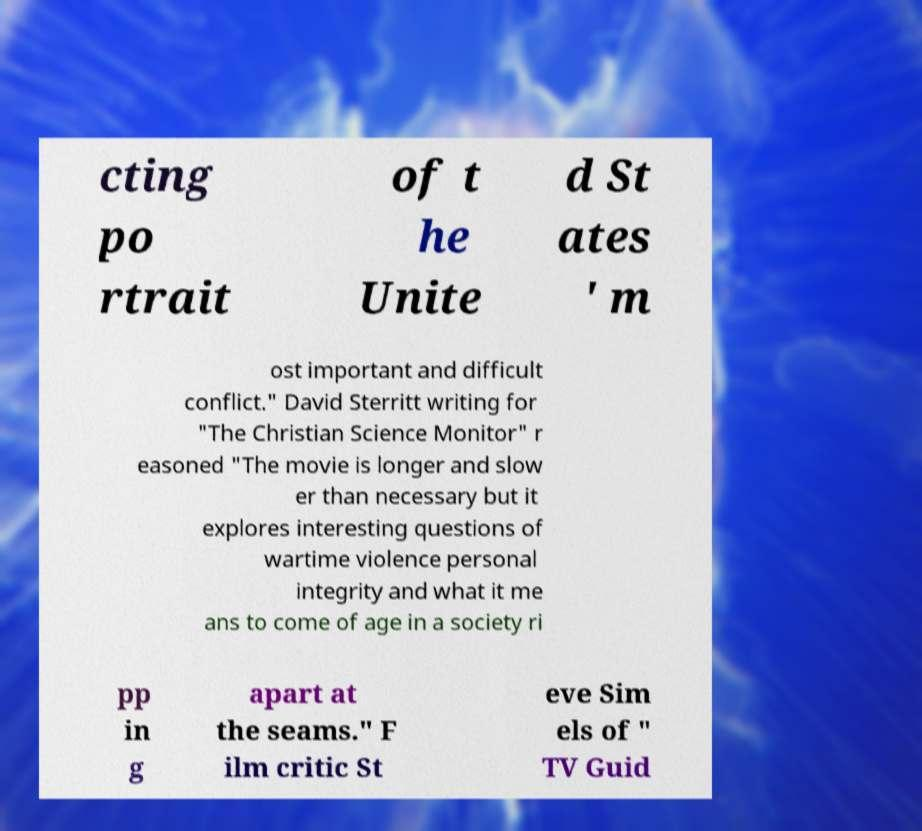Could you extract and type out the text from this image? cting po rtrait of t he Unite d St ates ' m ost important and difficult conflict." David Sterritt writing for "The Christian Science Monitor" r easoned "The movie is longer and slow er than necessary but it explores interesting questions of wartime violence personal integrity and what it me ans to come of age in a society ri pp in g apart at the seams." F ilm critic St eve Sim els of " TV Guid 